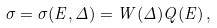<formula> <loc_0><loc_0><loc_500><loc_500>\sigma = \sigma ( E , \Delta ) = W ( \Delta ) Q ( E ) \, ,</formula> 